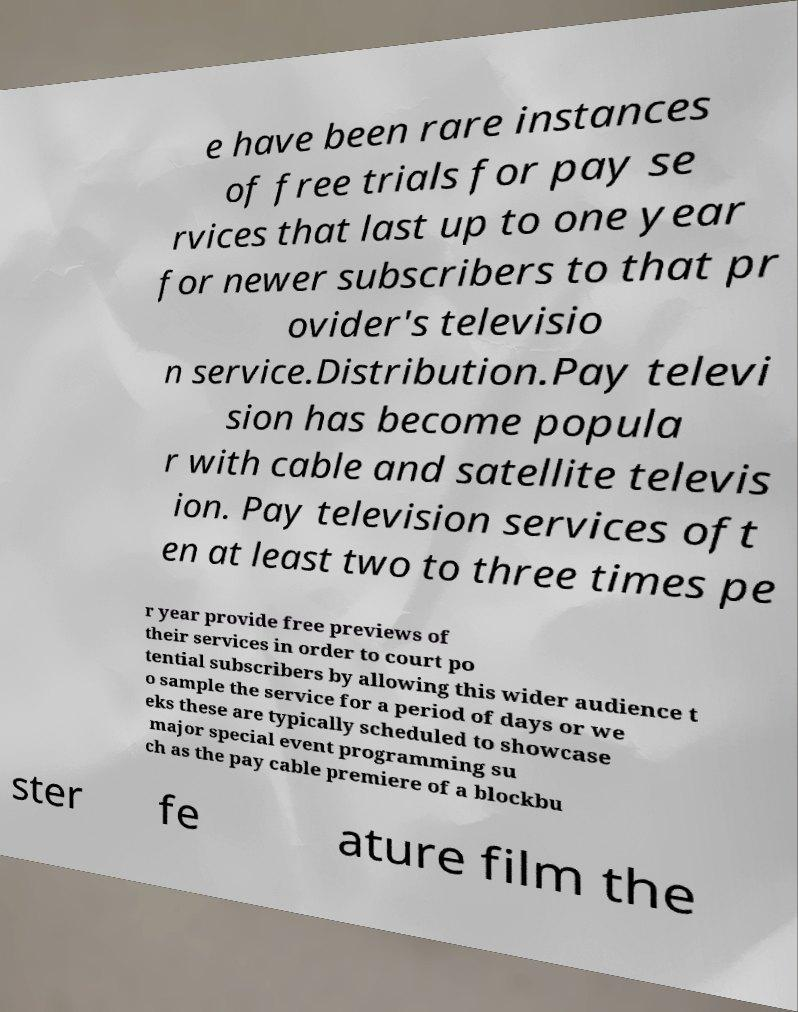Could you extract and type out the text from this image? e have been rare instances of free trials for pay se rvices that last up to one year for newer subscribers to that pr ovider's televisio n service.Distribution.Pay televi sion has become popula r with cable and satellite televis ion. Pay television services oft en at least two to three times pe r year provide free previews of their services in order to court po tential subscribers by allowing this wider audience t o sample the service for a period of days or we eks these are typically scheduled to showcase major special event programming su ch as the pay cable premiere of a blockbu ster fe ature film the 